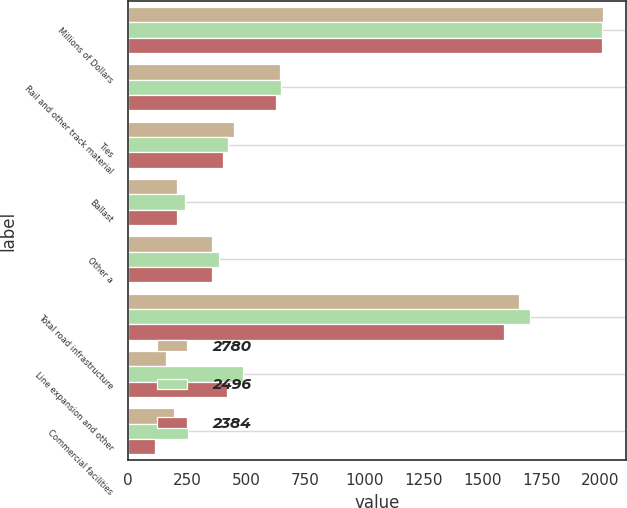<chart> <loc_0><loc_0><loc_500><loc_500><stacked_bar_chart><ecel><fcel>Millions of Dollars<fcel>Rail and other track material<fcel>Ties<fcel>Ballast<fcel>Other a<fcel>Total road infrastructure<fcel>Line expansion and other<fcel>Commercial facilities<nl><fcel>2780<fcel>2009<fcel>644<fcel>449<fcel>208<fcel>354<fcel>1655<fcel>162<fcel>193<nl><fcel>2496<fcel>2008<fcel>646<fcel>425<fcel>243<fcel>386<fcel>1700<fcel>488<fcel>254<nl><fcel>2384<fcel>2007<fcel>628<fcel>404<fcel>206<fcel>355<fcel>1593<fcel>419<fcel>115<nl></chart> 